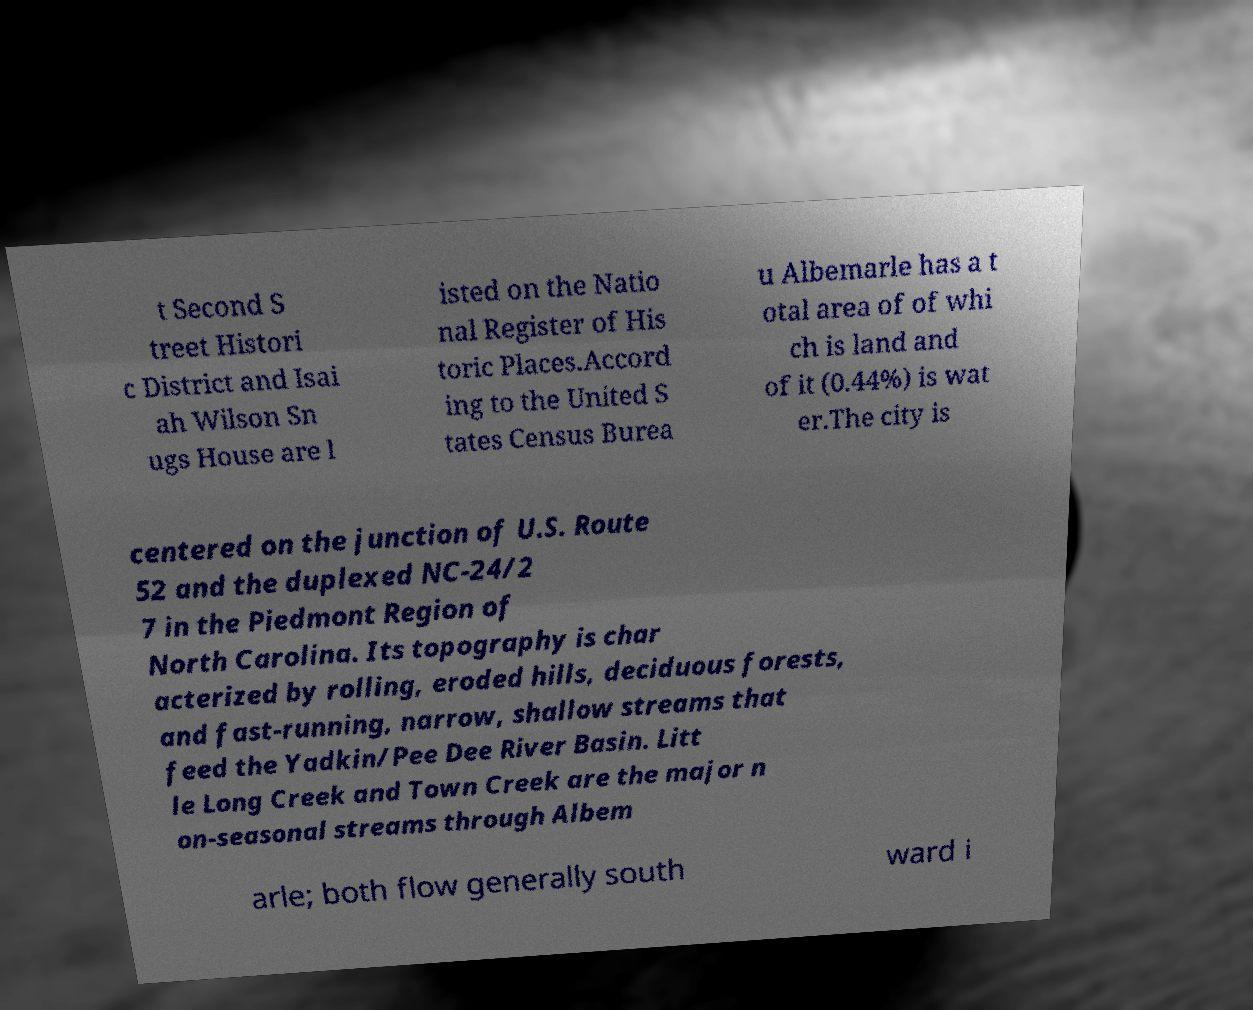I need the written content from this picture converted into text. Can you do that? t Second S treet Histori c District and Isai ah Wilson Sn ugs House are l isted on the Natio nal Register of His toric Places.Accord ing to the United S tates Census Burea u Albemarle has a t otal area of of whi ch is land and of it (0.44%) is wat er.The city is centered on the junction of U.S. Route 52 and the duplexed NC-24/2 7 in the Piedmont Region of North Carolina. Its topography is char acterized by rolling, eroded hills, deciduous forests, and fast-running, narrow, shallow streams that feed the Yadkin/Pee Dee River Basin. Litt le Long Creek and Town Creek are the major n on-seasonal streams through Albem arle; both flow generally south ward i 